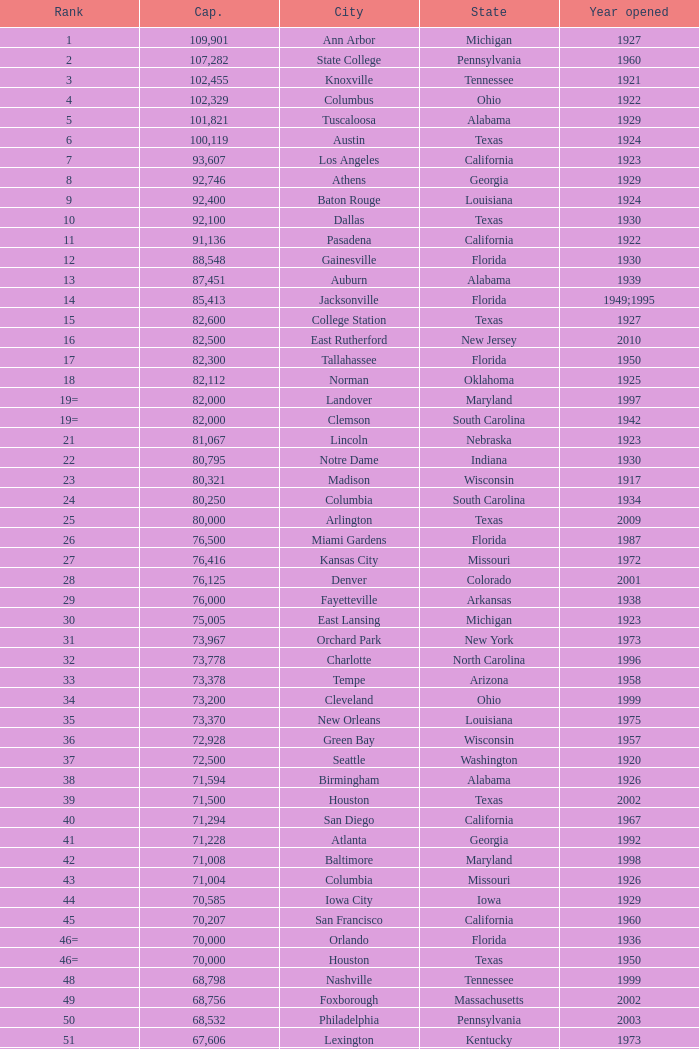What is the city in Alabama that opened in 1996? Huntsville. 